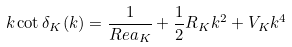Convert formula to latex. <formula><loc_0><loc_0><loc_500><loc_500>k \cot \delta _ { K } ( k ) = \frac { 1 } { R e a _ { K } } + \frac { 1 } { 2 } R _ { K } k ^ { 2 } + V _ { K } k ^ { 4 }</formula> 